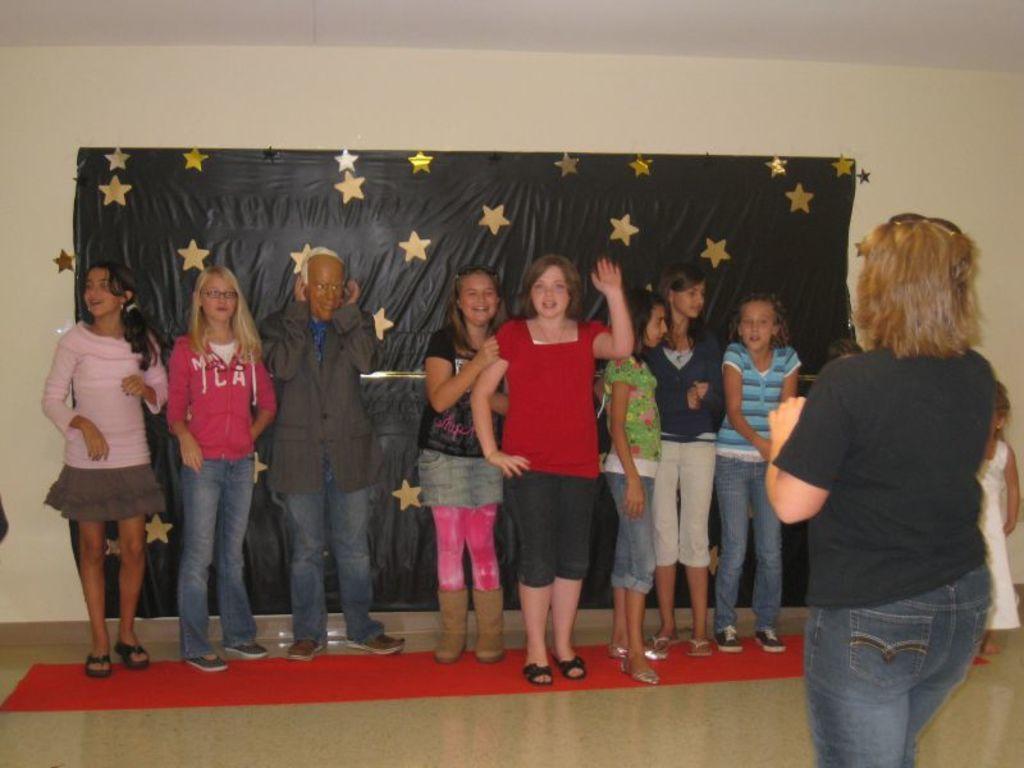Could you give a brief overview of what you see in this image? In this image there are a few people standing on the red carpet with a smile. On the right side of the image there is another person standing. In the background there are stars on the black color sheet, which is attached to the wall. 